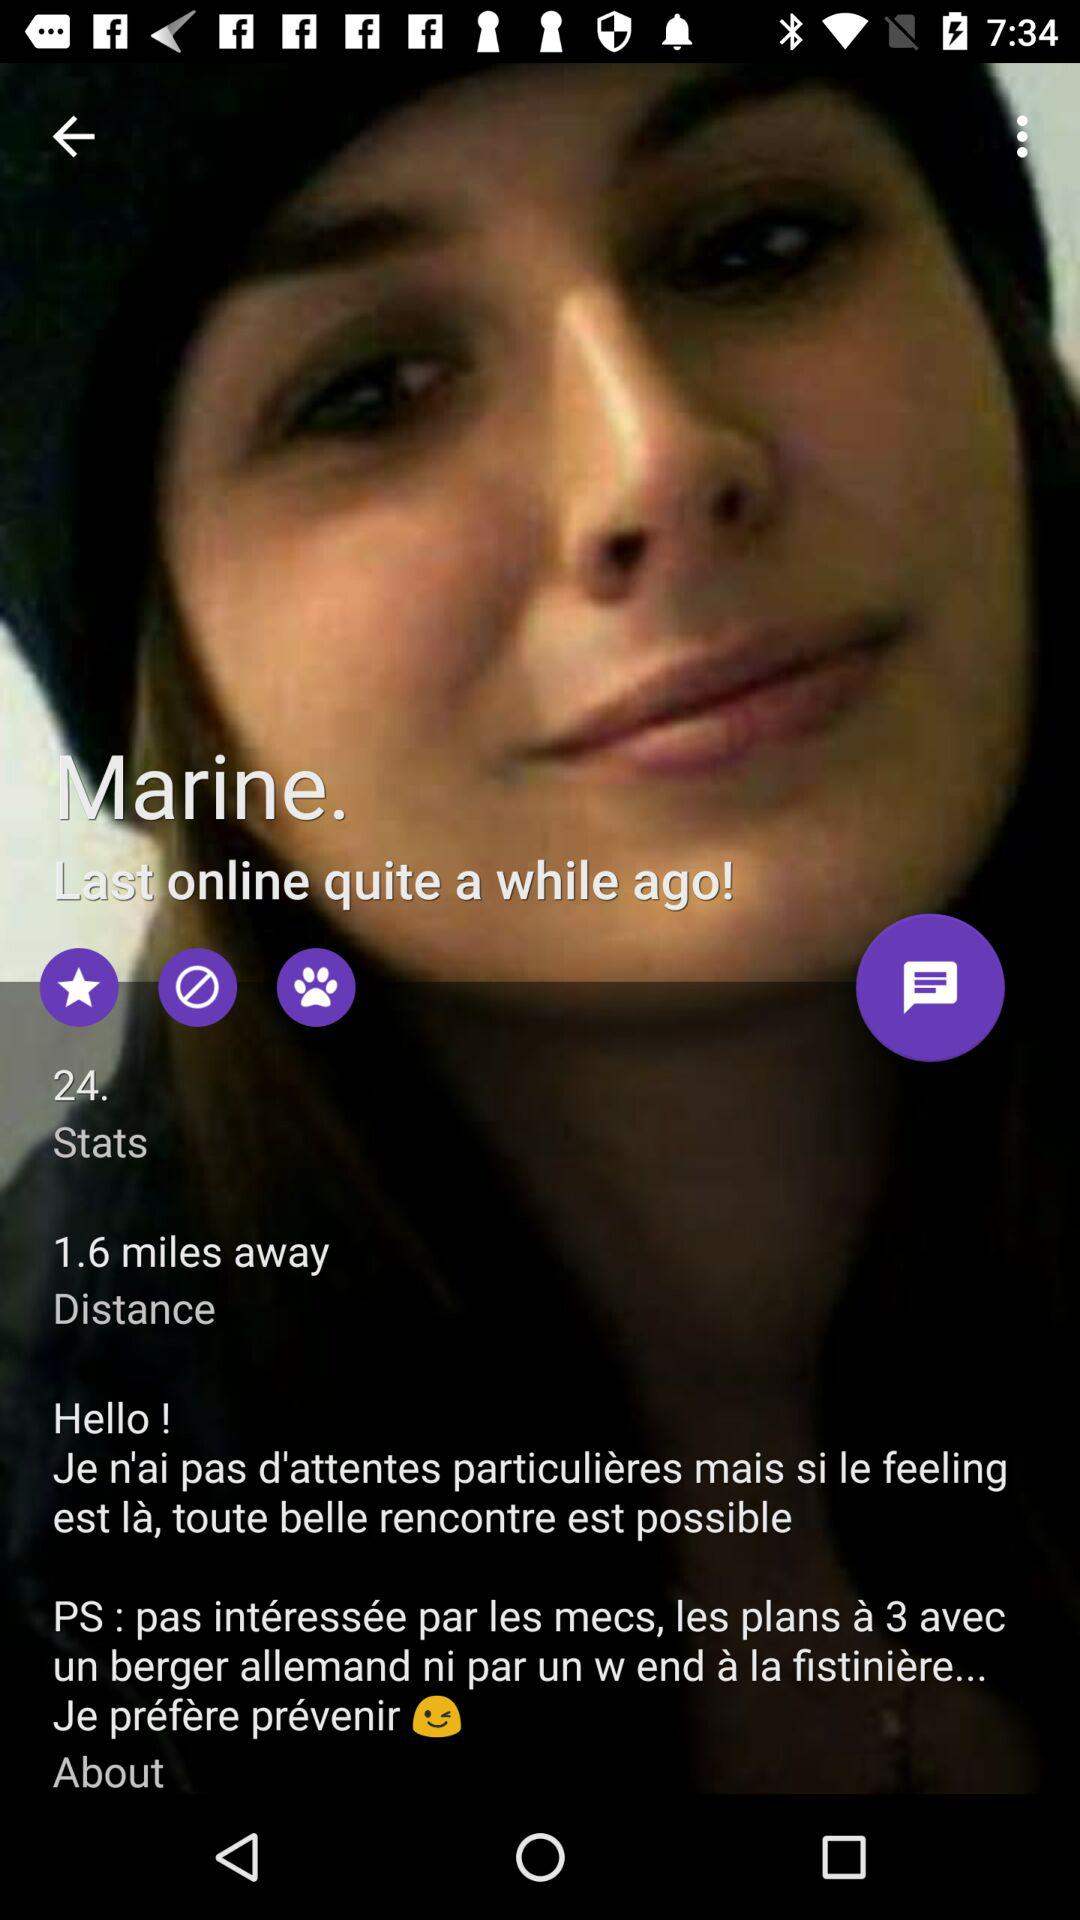What is the maximum distance from the user that this profile is?
Answer the question using a single word or phrase. 1.6 miles 